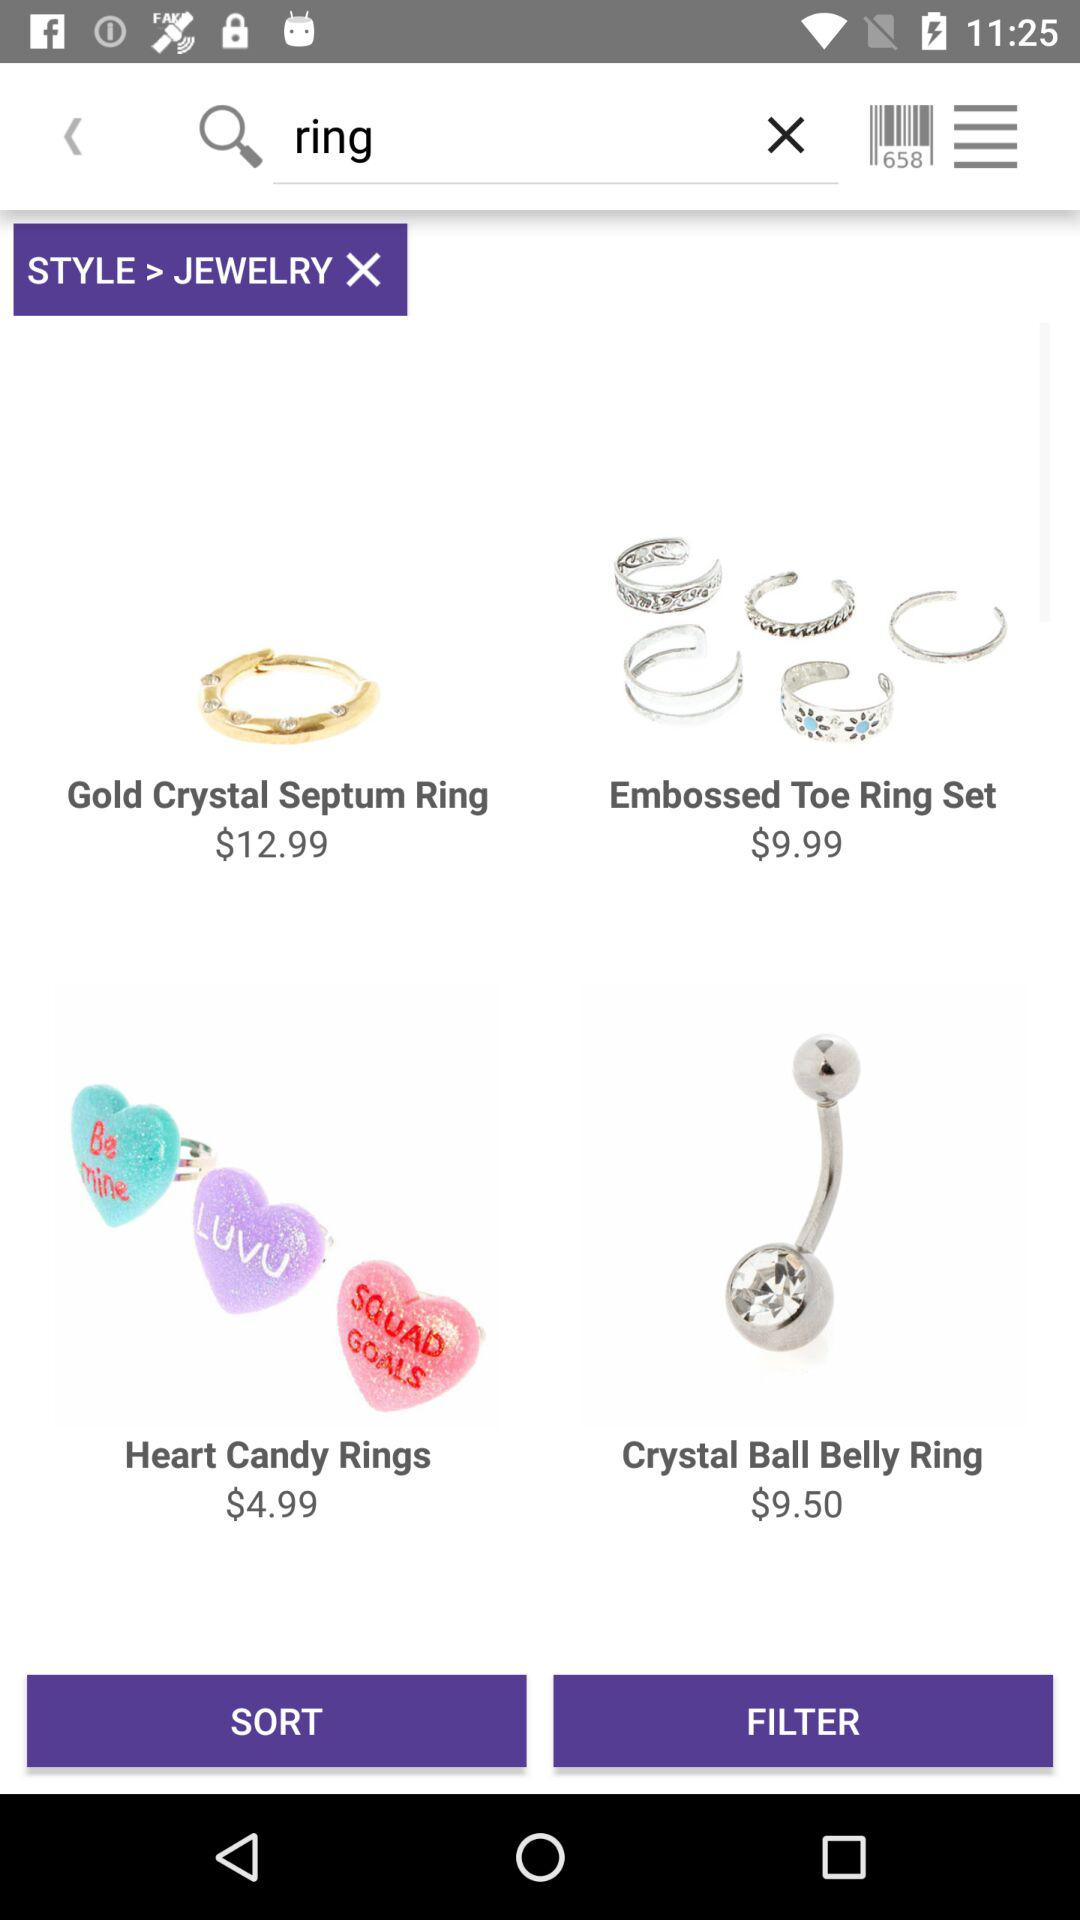What is written in the search box? In the search box, "ring" is written. 